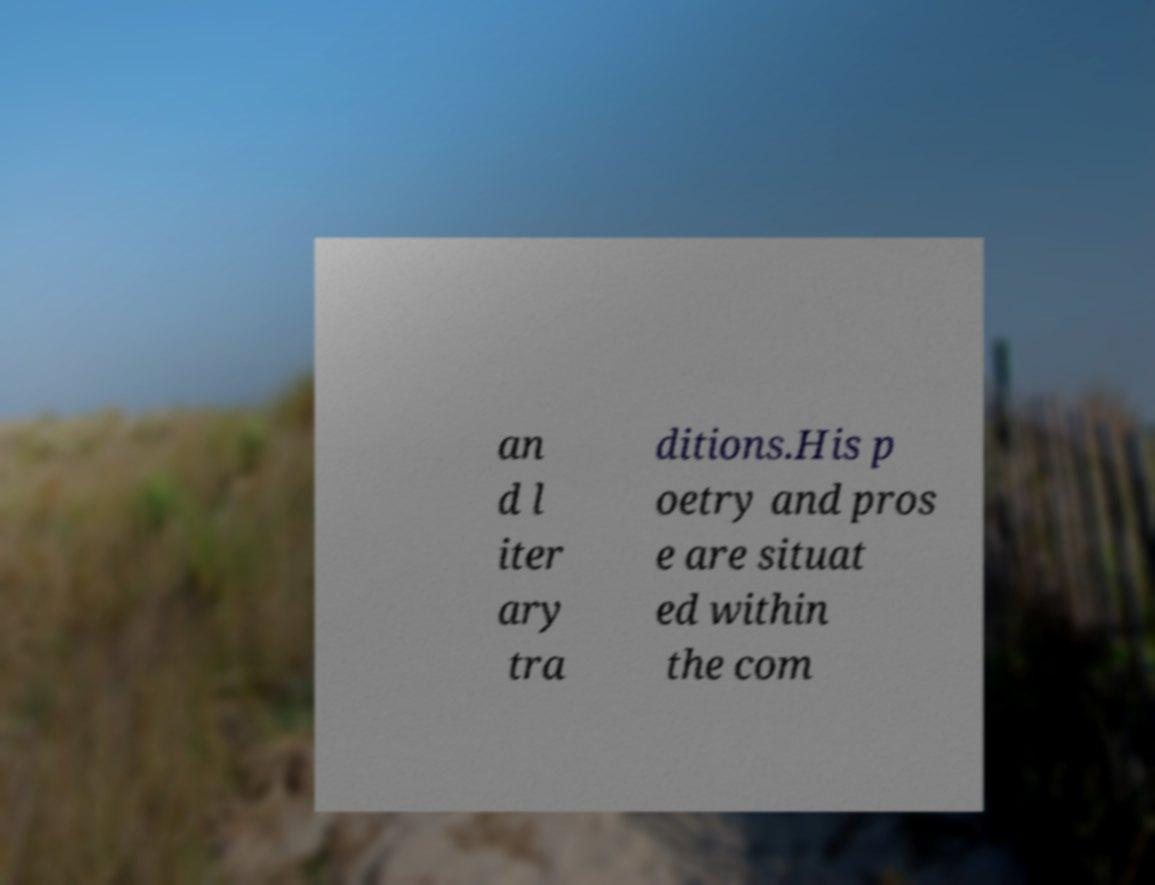Please identify and transcribe the text found in this image. an d l iter ary tra ditions.His p oetry and pros e are situat ed within the com 